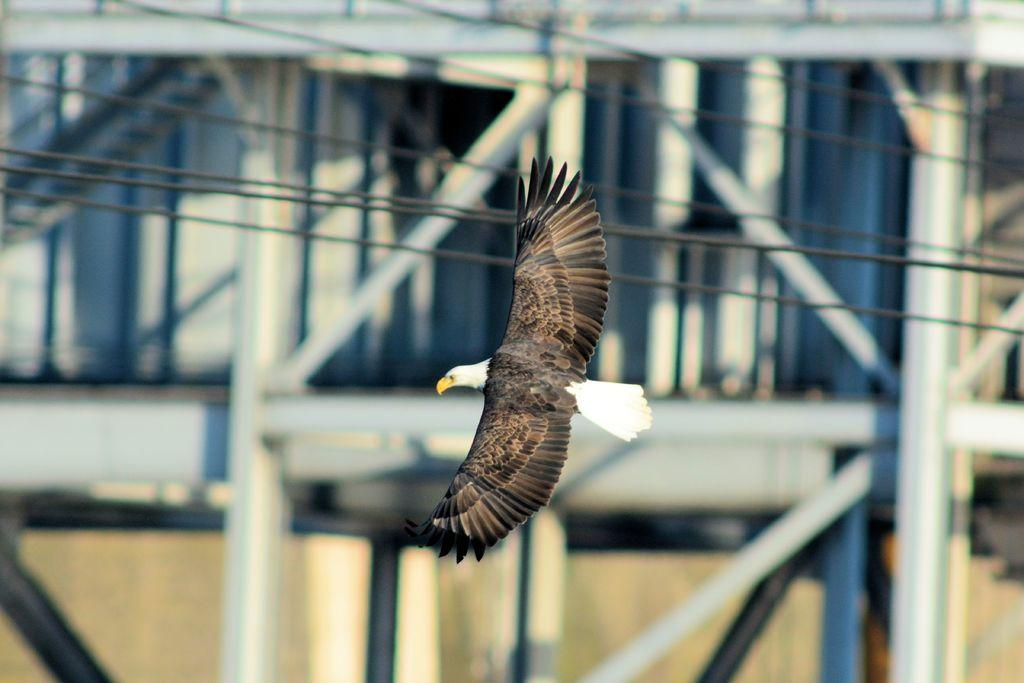What is the main subject of the image? The main subject of the image is a bird flying. Can you describe the background of the image? The background of the image includes wires and rods. What type of oatmeal is being served at the cemetery in the image? There is no oatmeal or cemetery present in the image; it features a bird flying with wires and rods in the background. 